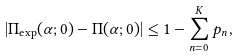<formula> <loc_0><loc_0><loc_500><loc_500>| \Pi _ { \text {exp} } ( \alpha ; 0 ) - \Pi ( \alpha ; 0 ) | \leq 1 - \sum _ { n = 0 } ^ { K } p _ { n } ,</formula> 